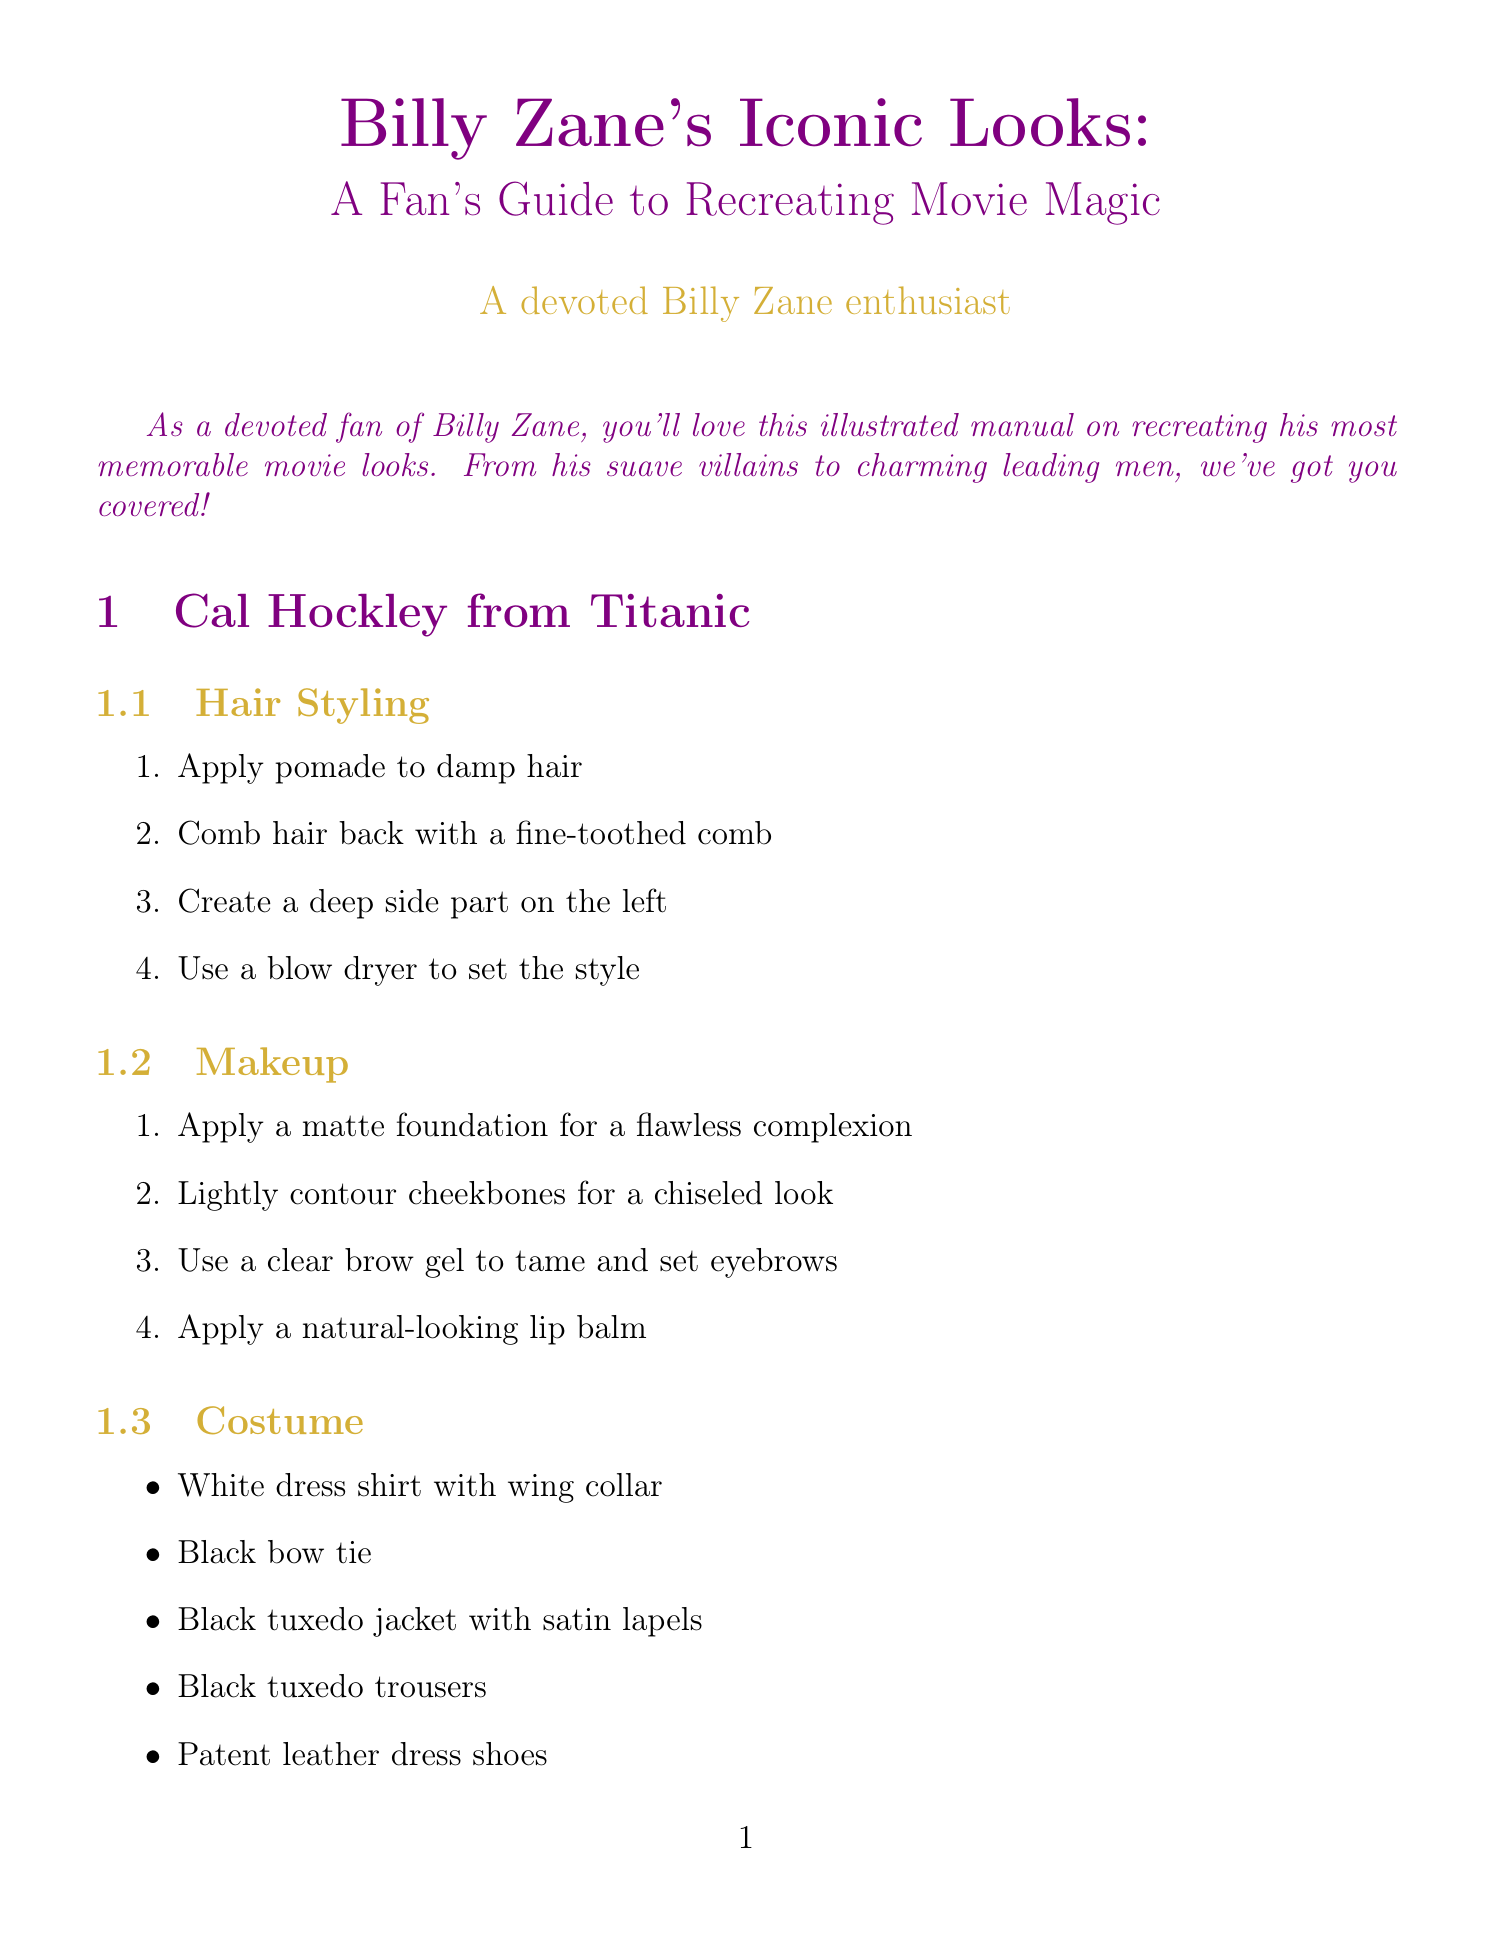What is the title of the manual? The title is presented at the beginning of the document.
Answer: Billy Zane's Iconic Looks: A Fan's Guide to Recreating Movie Magic How many iconic looks are detailed in the manual? The document lists four distinct characters and a bonus section, totaling five looks.
Answer: Five What character is associated with the costume items "Purple bodysuit with built-in muscles"? The document details the costumes for each character, linking them to specific looks.
Answer: Kit Walker from The Phantom What is the purpose of the bonus section? The bonus section is designed to provide guidance for a specific style related to Billy Zane.
Answer: To achieve the perfect smooth dome What is one item from the costume for Cal Hockley? Each character's costume includes specific items mentioned in the relevant sections.
Answer: Black tuxedo jacket with satin lapels What makeup step is recommended for John Wheeler? The makeup section includes specific steps for achieving a particular look associated with each character.
Answer: Use a brown eyebrow pencil to slightly darken and define brows What type of shoes are listed in Mark Cordell's costume? The document specifies the types of items related to each character's look.
Answer: Weathered leather boots Which character requires "wearing black briefs over a bodysuit"? The costume details for each character highlight specific outfit choices.
Answer: Kit Walker from The Phantom 